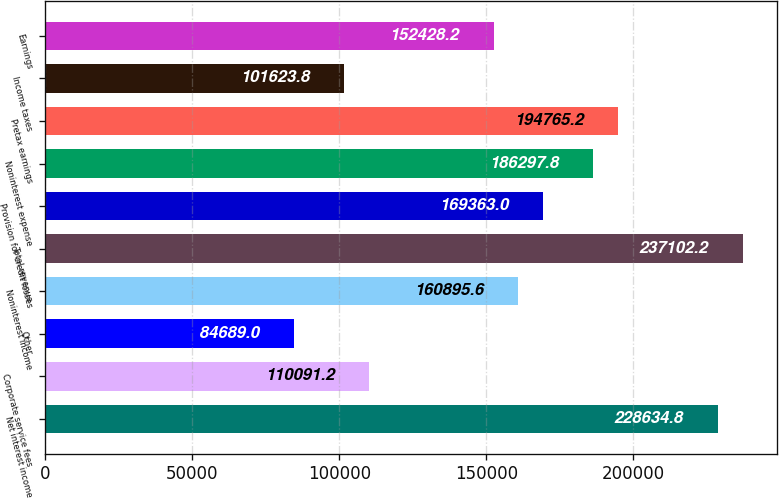<chart> <loc_0><loc_0><loc_500><loc_500><bar_chart><fcel>Net interest income<fcel>Corporate service fees<fcel>Other<fcel>Noninterest income<fcel>Total revenue<fcel>Provision for credit losses<fcel>Noninterest expense<fcel>Pretax earnings<fcel>Income taxes<fcel>Earnings<nl><fcel>228635<fcel>110091<fcel>84689<fcel>160896<fcel>237102<fcel>169363<fcel>186298<fcel>194765<fcel>101624<fcel>152428<nl></chart> 